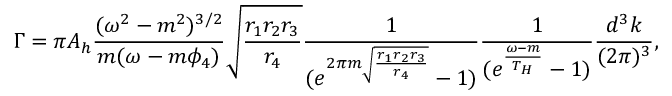<formula> <loc_0><loc_0><loc_500><loc_500>\Gamma = \pi A _ { h } \frac { ( \omega ^ { 2 } - m ^ { 2 } ) ^ { 3 / 2 } } { m ( \omega - m \phi _ { 4 } ) } \sqrt { \frac { r _ { 1 } r _ { 2 } r _ { 3 } } { r _ { 4 } } } \frac { 1 } { ( e ^ { 2 \pi m \sqrt { \frac { r _ { 1 } r _ { 2 } r _ { 3 } } { r _ { 4 } } } } - 1 ) } \frac { 1 } { ( e ^ { \frac { \omega - m } { T _ { H } } } - 1 ) } \frac { d ^ { 3 } k } { ( 2 \pi ) ^ { 3 } } ,</formula> 